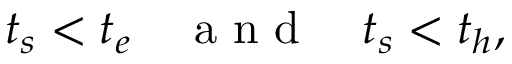Convert formula to latex. <formula><loc_0><loc_0><loc_500><loc_500>t _ { s } < t _ { e } a n d t _ { s } < t _ { h } ,</formula> 